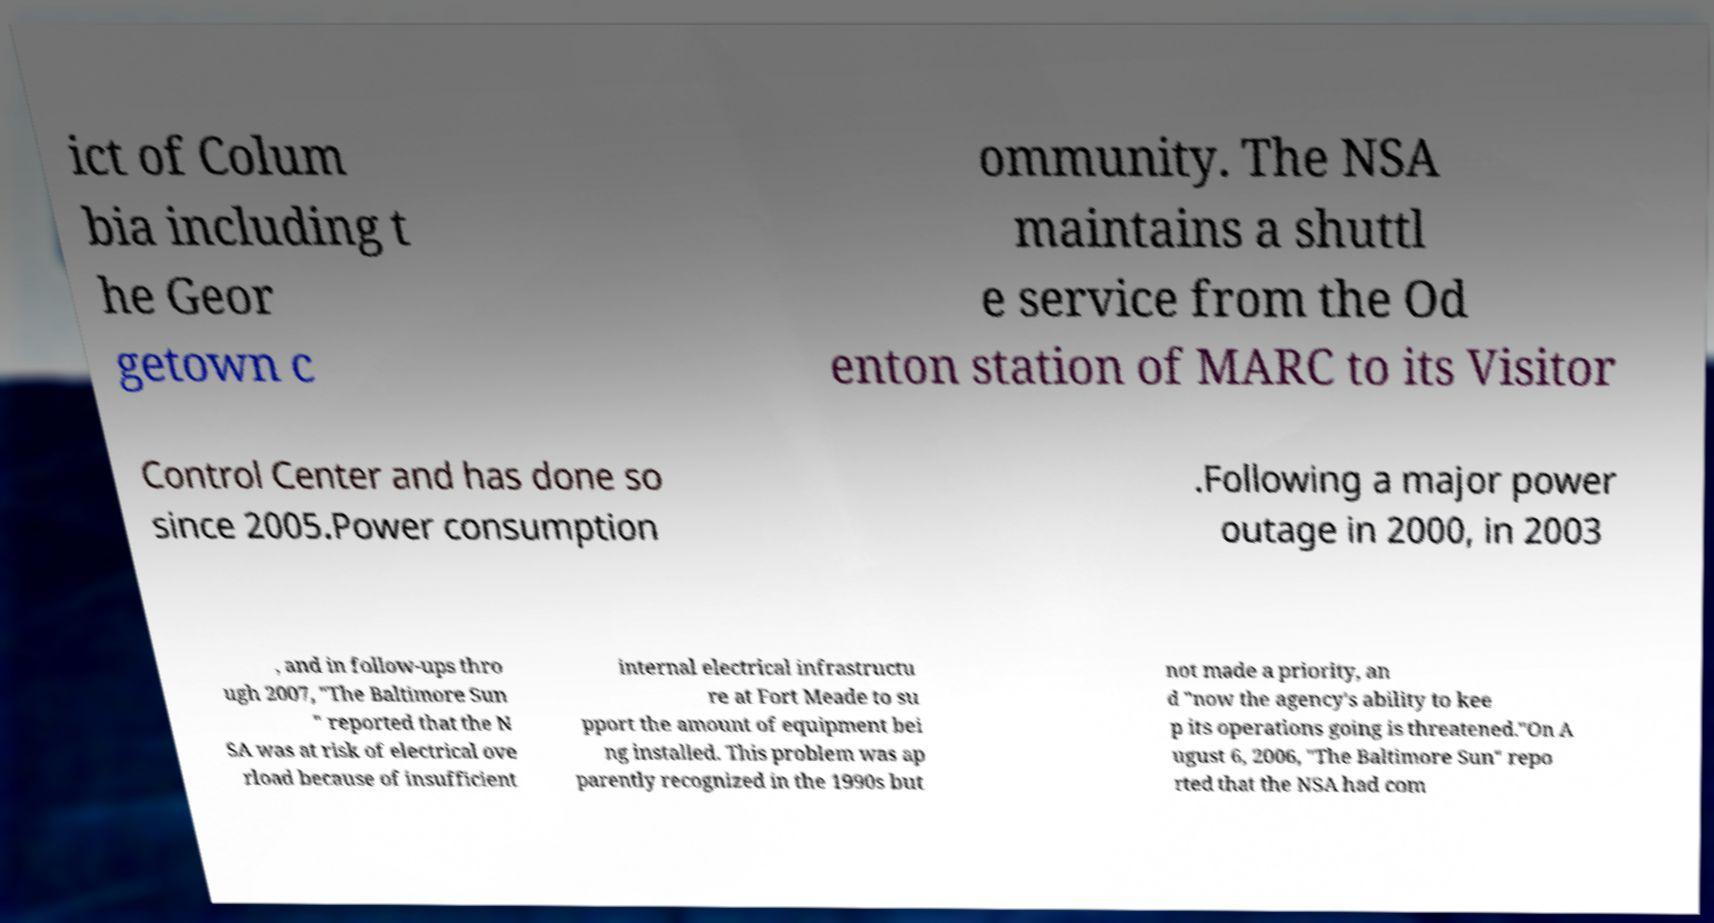Could you extract and type out the text from this image? ict of Colum bia including t he Geor getown c ommunity. The NSA maintains a shuttl e service from the Od enton station of MARC to its Visitor Control Center and has done so since 2005.Power consumption .Following a major power outage in 2000, in 2003 , and in follow-ups thro ugh 2007, "The Baltimore Sun " reported that the N SA was at risk of electrical ove rload because of insufficient internal electrical infrastructu re at Fort Meade to su pport the amount of equipment bei ng installed. This problem was ap parently recognized in the 1990s but not made a priority, an d "now the agency's ability to kee p its operations going is threatened."On A ugust 6, 2006, "The Baltimore Sun" repo rted that the NSA had com 